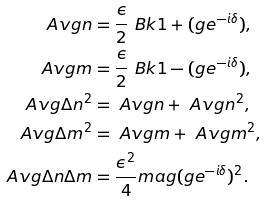<formula> <loc_0><loc_0><loc_500><loc_500>\ A v g { n } & = \frac { \epsilon } { 2 } \ B k { 1 + \real ( g e ^ { - i \delta } ) } , \\ \ A v g { m } & = \frac { \epsilon } { 2 } \ B k { 1 - \real ( g e ^ { - i \delta } ) } , \\ \ A v g { \Delta n ^ { 2 } } & = \ A v g { n } + \ A v g { n } ^ { 2 } , \\ \ A v g { \Delta m ^ { 2 } } & = \ A v g { m } + \ A v g { m } ^ { 2 } , \\ \ A v g { \Delta n \Delta m } & = \frac { \epsilon ^ { 2 } } { 4 } \i m a g ( g e ^ { - i \delta } ) ^ { 2 } .</formula> 